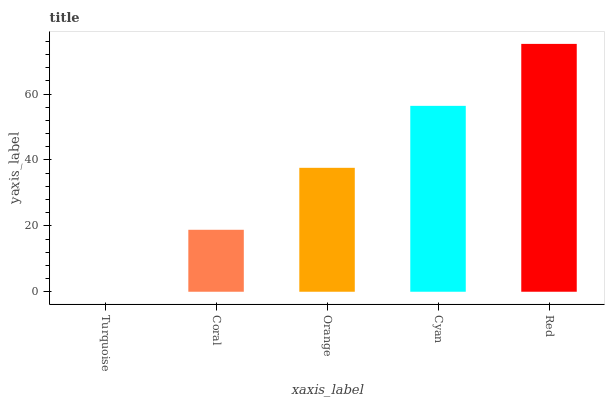Is Coral the minimum?
Answer yes or no. No. Is Coral the maximum?
Answer yes or no. No. Is Coral greater than Turquoise?
Answer yes or no. Yes. Is Turquoise less than Coral?
Answer yes or no. Yes. Is Turquoise greater than Coral?
Answer yes or no. No. Is Coral less than Turquoise?
Answer yes or no. No. Is Orange the high median?
Answer yes or no. Yes. Is Orange the low median?
Answer yes or no. Yes. Is Coral the high median?
Answer yes or no. No. Is Red the low median?
Answer yes or no. No. 